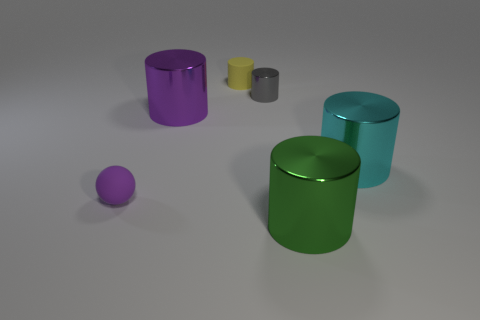If this is a scaled model, what might the real-world equivalent look like? If this is a scaled model, the real-world equivalent of these objects might be large industrial containers such as storage drums for liquids or solids. They could also resemble modernist furniture pieces if the scale and materials were suitable for functional design. 